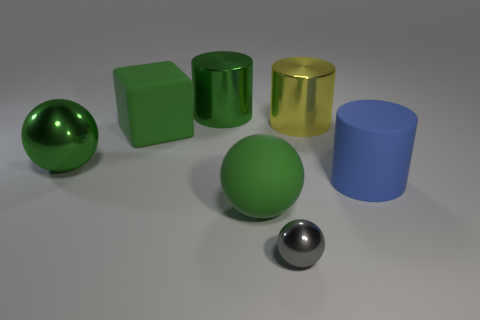Can you describe the textures of the objects in this image? Certainly! The objects exhibit a variety of textures: the spheres and the cylinders have smooth, seemingly polished surfaces. The large green and yellow objects have a high-gloss finish, reflecting light prominently, while the blue cylinder has a more matte appearance, diffusing light more gently. 